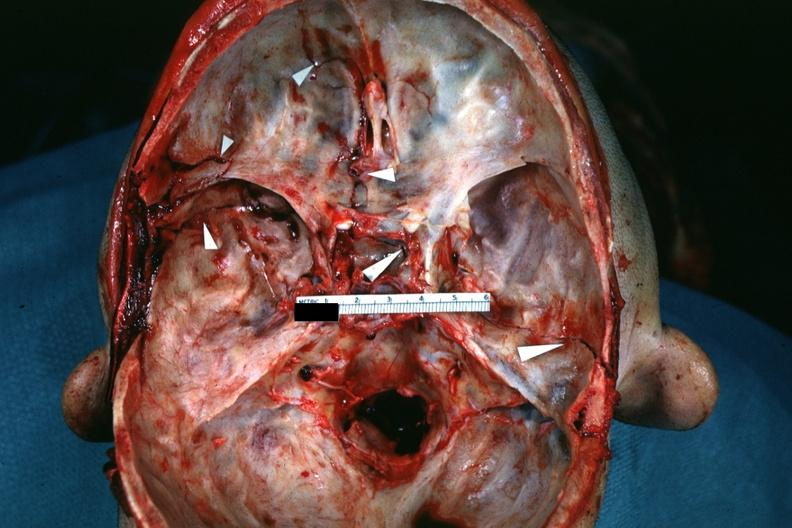what is slide?
Answer the question using a single word or phrase. Fractures brain which and close-up view of these fractures 